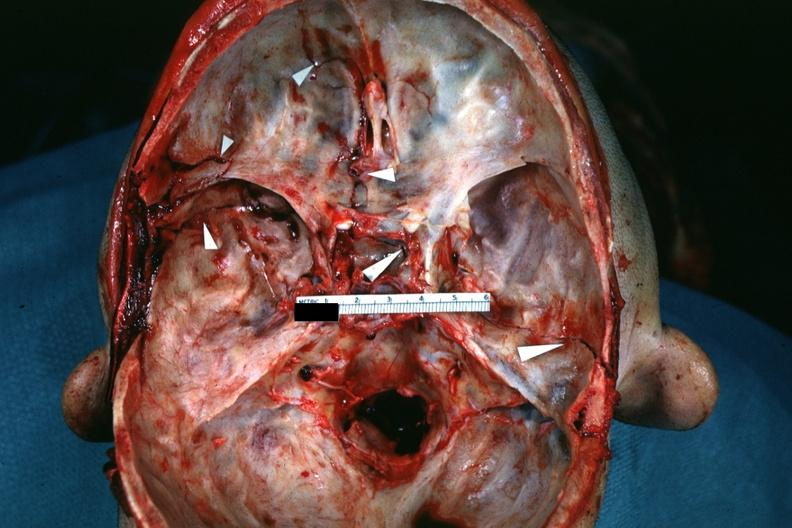what is slide?
Answer the question using a single word or phrase. Fractures brain which and close-up view of these fractures 